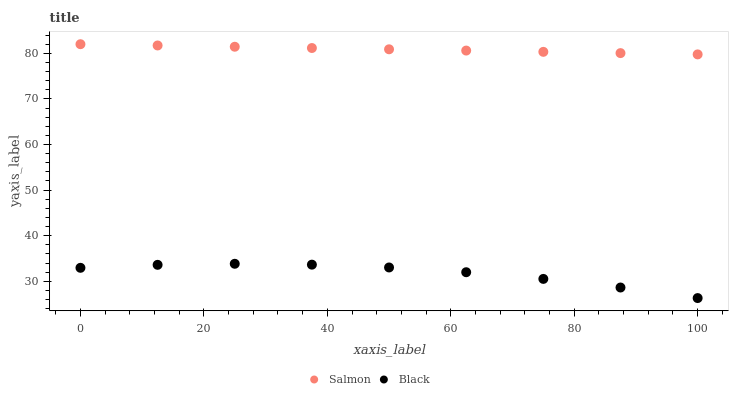Does Black have the minimum area under the curve?
Answer yes or no. Yes. Does Salmon have the maximum area under the curve?
Answer yes or no. Yes. Does Salmon have the minimum area under the curve?
Answer yes or no. No. Is Salmon the smoothest?
Answer yes or no. Yes. Is Black the roughest?
Answer yes or no. Yes. Is Salmon the roughest?
Answer yes or no. No. Does Black have the lowest value?
Answer yes or no. Yes. Does Salmon have the lowest value?
Answer yes or no. No. Does Salmon have the highest value?
Answer yes or no. Yes. Is Black less than Salmon?
Answer yes or no. Yes. Is Salmon greater than Black?
Answer yes or no. Yes. Does Black intersect Salmon?
Answer yes or no. No. 